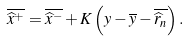Convert formula to latex. <formula><loc_0><loc_0><loc_500><loc_500>\overline { \widehat { x } ^ { + } } = \overline { \widehat { x } ^ { - } } + K \left ( y - \overline { y } - \overline { \widehat { r } _ { n } } \right ) .</formula> 